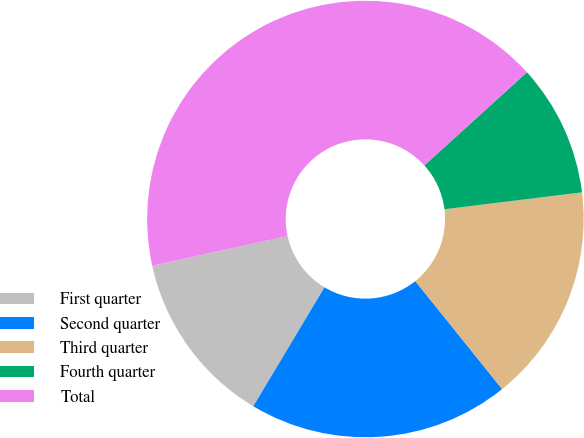<chart> <loc_0><loc_0><loc_500><loc_500><pie_chart><fcel>First quarter<fcel>Second quarter<fcel>Third quarter<fcel>Fourth quarter<fcel>Total<nl><fcel>12.98%<fcel>19.36%<fcel>16.17%<fcel>9.79%<fcel>41.7%<nl></chart> 